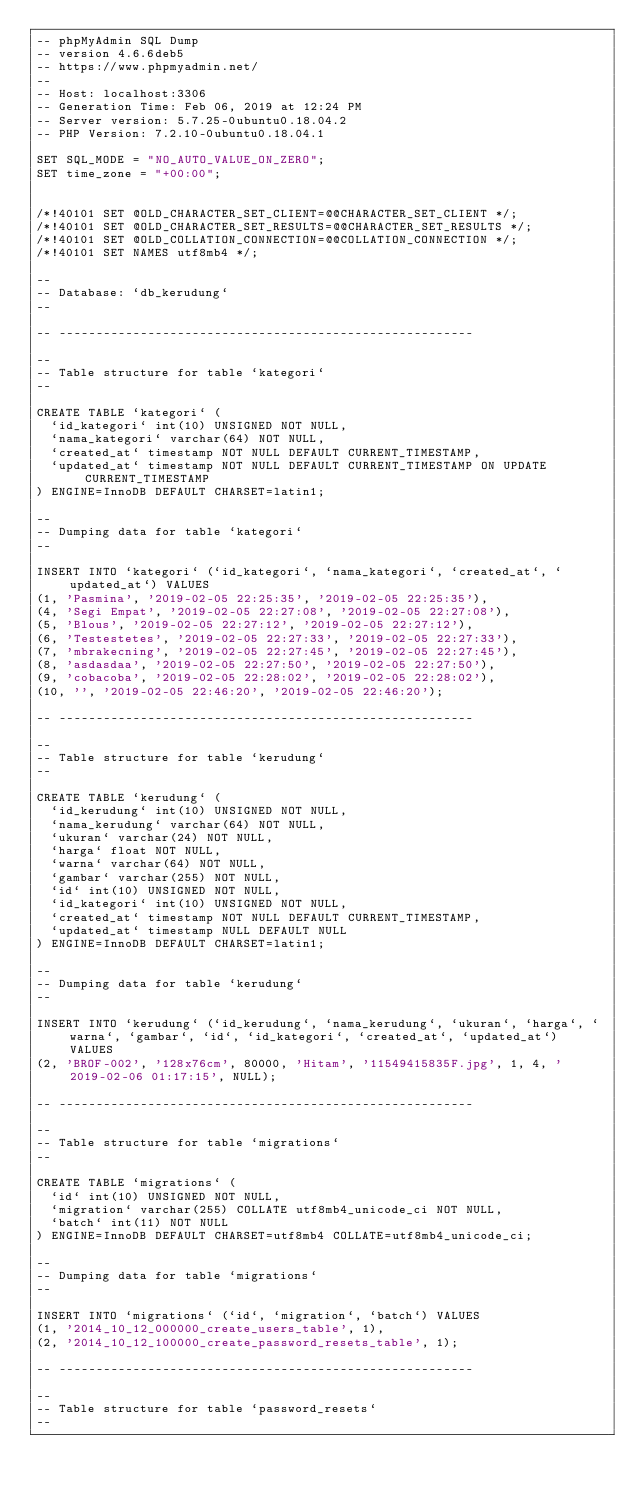Convert code to text. <code><loc_0><loc_0><loc_500><loc_500><_SQL_>-- phpMyAdmin SQL Dump
-- version 4.6.6deb5
-- https://www.phpmyadmin.net/
--
-- Host: localhost:3306
-- Generation Time: Feb 06, 2019 at 12:24 PM
-- Server version: 5.7.25-0ubuntu0.18.04.2
-- PHP Version: 7.2.10-0ubuntu0.18.04.1

SET SQL_MODE = "NO_AUTO_VALUE_ON_ZERO";
SET time_zone = "+00:00";


/*!40101 SET @OLD_CHARACTER_SET_CLIENT=@@CHARACTER_SET_CLIENT */;
/*!40101 SET @OLD_CHARACTER_SET_RESULTS=@@CHARACTER_SET_RESULTS */;
/*!40101 SET @OLD_COLLATION_CONNECTION=@@COLLATION_CONNECTION */;
/*!40101 SET NAMES utf8mb4 */;

--
-- Database: `db_kerudung`
--

-- --------------------------------------------------------

--
-- Table structure for table `kategori`
--

CREATE TABLE `kategori` (
  `id_kategori` int(10) UNSIGNED NOT NULL,
  `nama_kategori` varchar(64) NOT NULL,
  `created_at` timestamp NOT NULL DEFAULT CURRENT_TIMESTAMP,
  `updated_at` timestamp NOT NULL DEFAULT CURRENT_TIMESTAMP ON UPDATE CURRENT_TIMESTAMP
) ENGINE=InnoDB DEFAULT CHARSET=latin1;

--
-- Dumping data for table `kategori`
--

INSERT INTO `kategori` (`id_kategori`, `nama_kategori`, `created_at`, `updated_at`) VALUES
(1, 'Pasmina', '2019-02-05 22:25:35', '2019-02-05 22:25:35'),
(4, 'Segi Empat', '2019-02-05 22:27:08', '2019-02-05 22:27:08'),
(5, 'Blous', '2019-02-05 22:27:12', '2019-02-05 22:27:12'),
(6, 'Testestetes', '2019-02-05 22:27:33', '2019-02-05 22:27:33'),
(7, 'mbrakecning', '2019-02-05 22:27:45', '2019-02-05 22:27:45'),
(8, 'asdasdaa', '2019-02-05 22:27:50', '2019-02-05 22:27:50'),
(9, 'cobacoba', '2019-02-05 22:28:02', '2019-02-05 22:28:02'),
(10, '', '2019-02-05 22:46:20', '2019-02-05 22:46:20');

-- --------------------------------------------------------

--
-- Table structure for table `kerudung`
--

CREATE TABLE `kerudung` (
  `id_kerudung` int(10) UNSIGNED NOT NULL,
  `nama_kerudung` varchar(64) NOT NULL,
  `ukuran` varchar(24) NOT NULL,
  `harga` float NOT NULL,
  `warna` varchar(64) NOT NULL,
  `gambar` varchar(255) NOT NULL,
  `id` int(10) UNSIGNED NOT NULL,
  `id_kategori` int(10) UNSIGNED NOT NULL,
  `created_at` timestamp NOT NULL DEFAULT CURRENT_TIMESTAMP,
  `updated_at` timestamp NULL DEFAULT NULL
) ENGINE=InnoDB DEFAULT CHARSET=latin1;

--
-- Dumping data for table `kerudung`
--

INSERT INTO `kerudung` (`id_kerudung`, `nama_kerudung`, `ukuran`, `harga`, `warna`, `gambar`, `id`, `id_kategori`, `created_at`, `updated_at`) VALUES
(2, 'BROF-002', '128x76cm', 80000, 'Hitam', '11549415835F.jpg', 1, 4, '2019-02-06 01:17:15', NULL);

-- --------------------------------------------------------

--
-- Table structure for table `migrations`
--

CREATE TABLE `migrations` (
  `id` int(10) UNSIGNED NOT NULL,
  `migration` varchar(255) COLLATE utf8mb4_unicode_ci NOT NULL,
  `batch` int(11) NOT NULL
) ENGINE=InnoDB DEFAULT CHARSET=utf8mb4 COLLATE=utf8mb4_unicode_ci;

--
-- Dumping data for table `migrations`
--

INSERT INTO `migrations` (`id`, `migration`, `batch`) VALUES
(1, '2014_10_12_000000_create_users_table', 1),
(2, '2014_10_12_100000_create_password_resets_table', 1);

-- --------------------------------------------------------

--
-- Table structure for table `password_resets`
--
</code> 